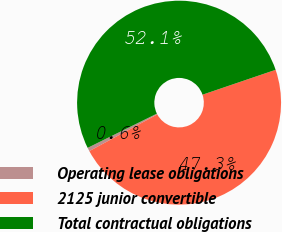Convert chart. <chart><loc_0><loc_0><loc_500><loc_500><pie_chart><fcel>Operating lease obligations<fcel>2125 junior convertible<fcel>Total contractual obligations<nl><fcel>0.57%<fcel>47.35%<fcel>52.08%<nl></chart> 